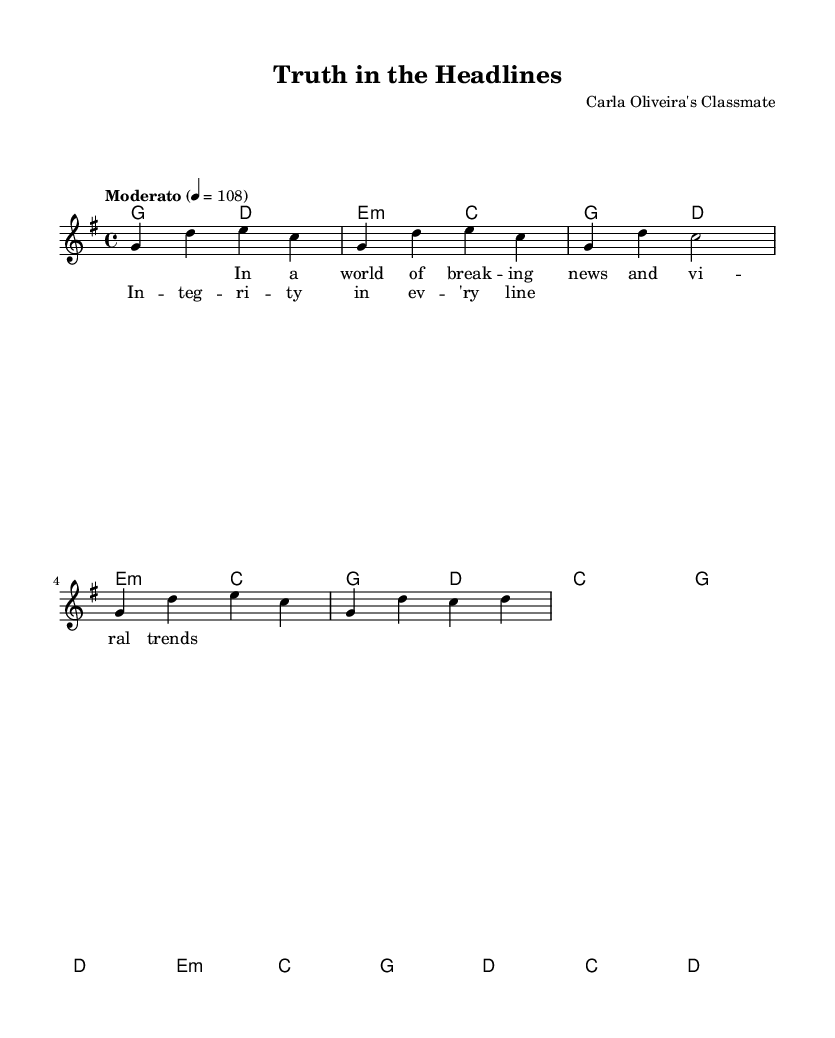What is the key signature of this music? The key signature is G major, which has one sharp (F#). This is visually indicated at the beginning of the sheet music next to the clef.
Answer: G major What is the time signature of this music? The time signature is 4/4, indicated at the beginning of the piece. This means there are four beats in each measure, and the quarter note gets one beat.
Answer: 4/4 What is the tempo marking of this piece? The tempo marking is Moderato, which implies a moderate speed. It is noted at the beginning of the music included as part of the global settings.
Answer: Moderato How many measures are in the provided melody? The melody contains eight measures, indicated by the four sections of music displayed within the melody lines. Each measure is separated by a vertical line.
Answer: Eight measures What is the mood indicated by the tempo and lyrics of this piece? The mood of the piece can be described as reflective or serious, suggested by the moderate tempo and the themes of integrity in journalism conveyed through the lyrics. This reflects the pop genre's tendency to address meaningful societal issues.
Answer: Reflective What chord follows the e minor chord in the first verse? The chord that follows the e minor chord is the C major chord, as seen in the harmony section accompanying the melody throughout that part of the verse.
Answer: C major What lyric is associated with the first measure of the verse? The lyric associated with the first measure is "In a world of break -- ing news and vi -- ral trends," which is written under the melody notes that correspond with the first measure of the verse.
Answer: "In a world of break -- ing news and vi -- ral trends." 